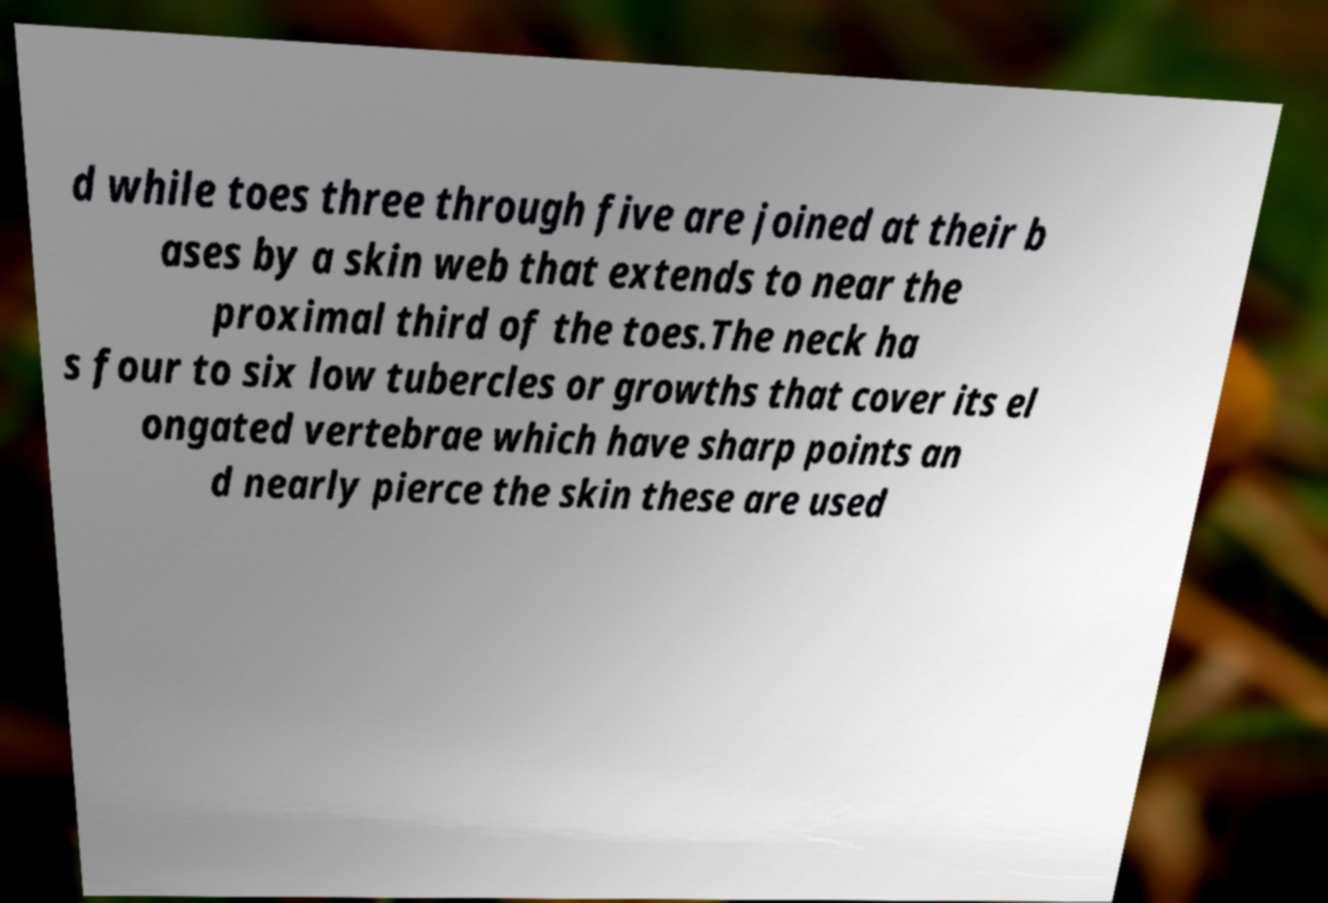Please read and relay the text visible in this image. What does it say? d while toes three through five are joined at their b ases by a skin web that extends to near the proximal third of the toes.The neck ha s four to six low tubercles or growths that cover its el ongated vertebrae which have sharp points an d nearly pierce the skin these are used 